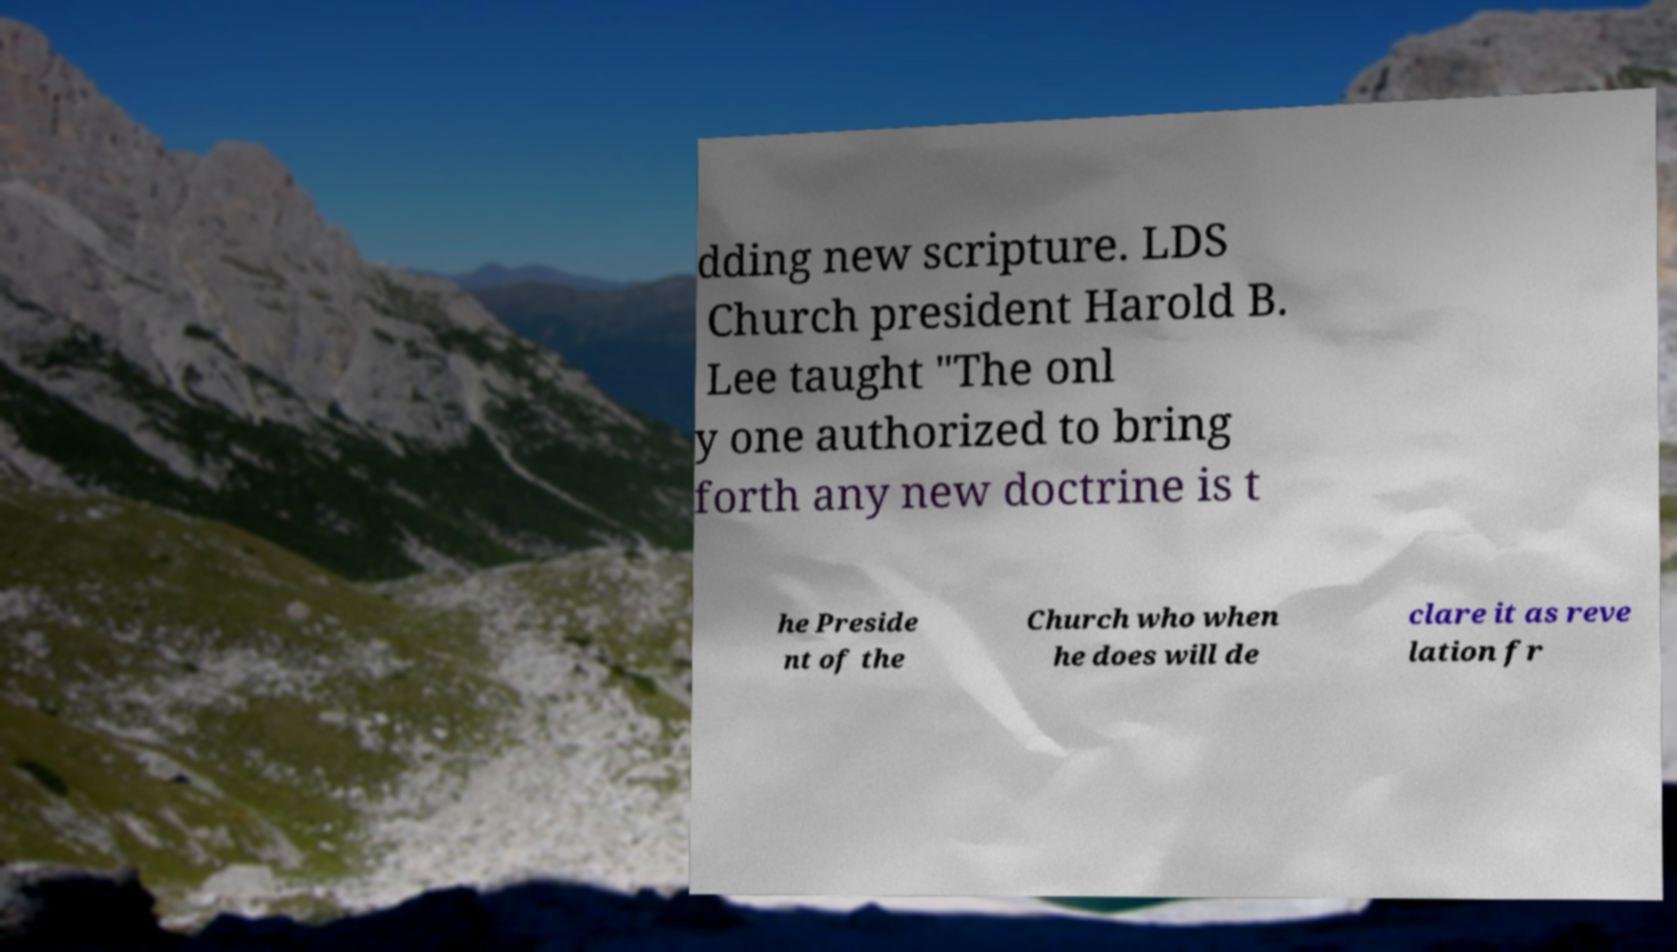Can you accurately transcribe the text from the provided image for me? dding new scripture. LDS Church president Harold B. Lee taught "The onl y one authorized to bring forth any new doctrine is t he Preside nt of the Church who when he does will de clare it as reve lation fr 